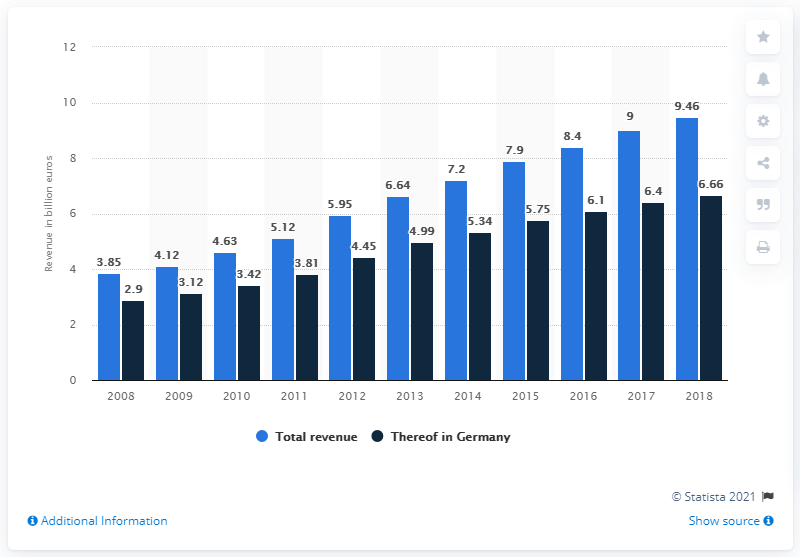Highlight a few significant elements in this photo. Rossman's revenue in 2018 was 9.46. The value of the highest bar is 9.46. In 2018, a total of 6.66 million euros was generated in the Federal Republic. The sum of the blue bars in 2008 and 2018 is 13.31. 